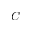<formula> <loc_0><loc_0><loc_500><loc_500>C</formula> 